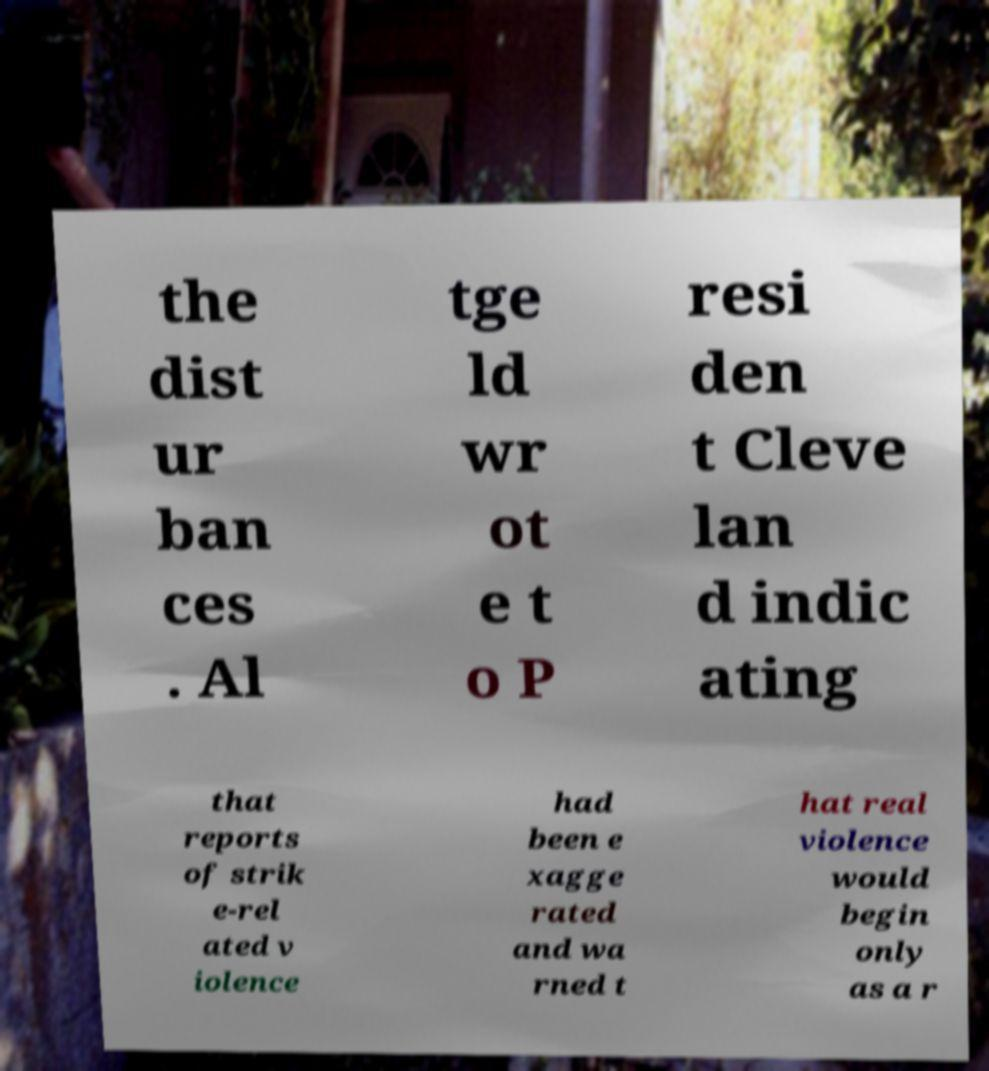Can you accurately transcribe the text from the provided image for me? the dist ur ban ces . Al tge ld wr ot e t o P resi den t Cleve lan d indic ating that reports of strik e-rel ated v iolence had been e xagge rated and wa rned t hat real violence would begin only as a r 